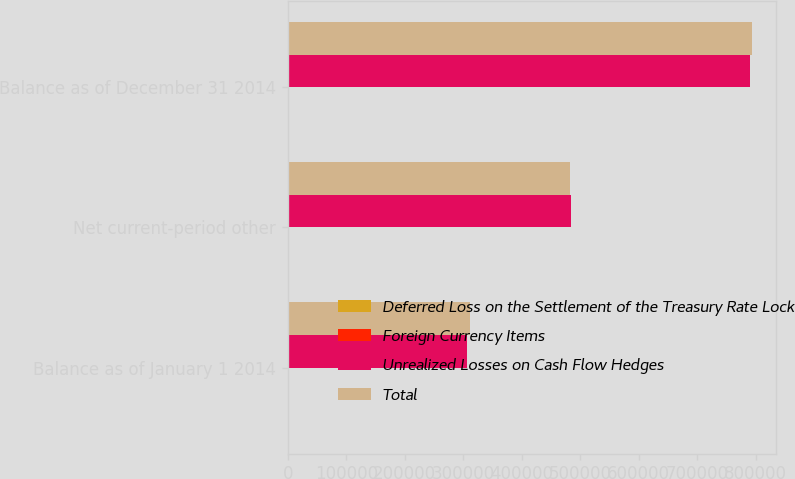<chart> <loc_0><loc_0><loc_500><loc_500><stacked_bar_chart><ecel><fcel>Balance as of January 1 2014<fcel>Net current-period other<fcel>Balance as of December 31 2014<nl><fcel>Deferred Loss on the Settlement of the Treasury Rate Lock<fcel>1869<fcel>524<fcel>1345<nl><fcel>Foreign Currency Items<fcel>3029<fcel>798<fcel>2231<nl><fcel>Unrealized Losses on Cash Flow Hedges<fcel>306322<fcel>484323<fcel>790645<nl><fcel>Total<fcel>311220<fcel>483001<fcel>794221<nl></chart> 